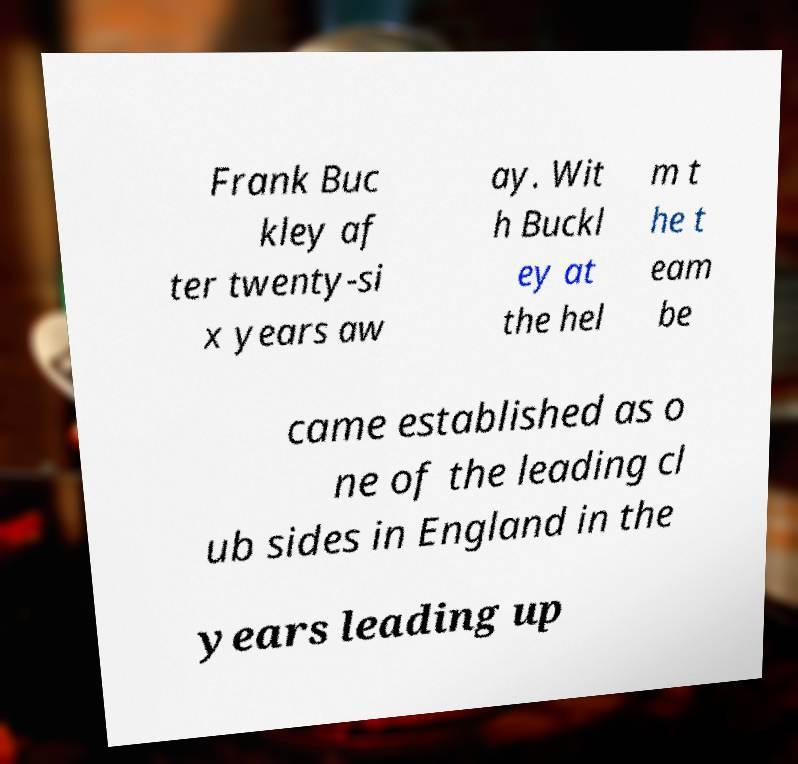What messages or text are displayed in this image? I need them in a readable, typed format. Frank Buc kley af ter twenty-si x years aw ay. Wit h Buckl ey at the hel m t he t eam be came established as o ne of the leading cl ub sides in England in the years leading up 